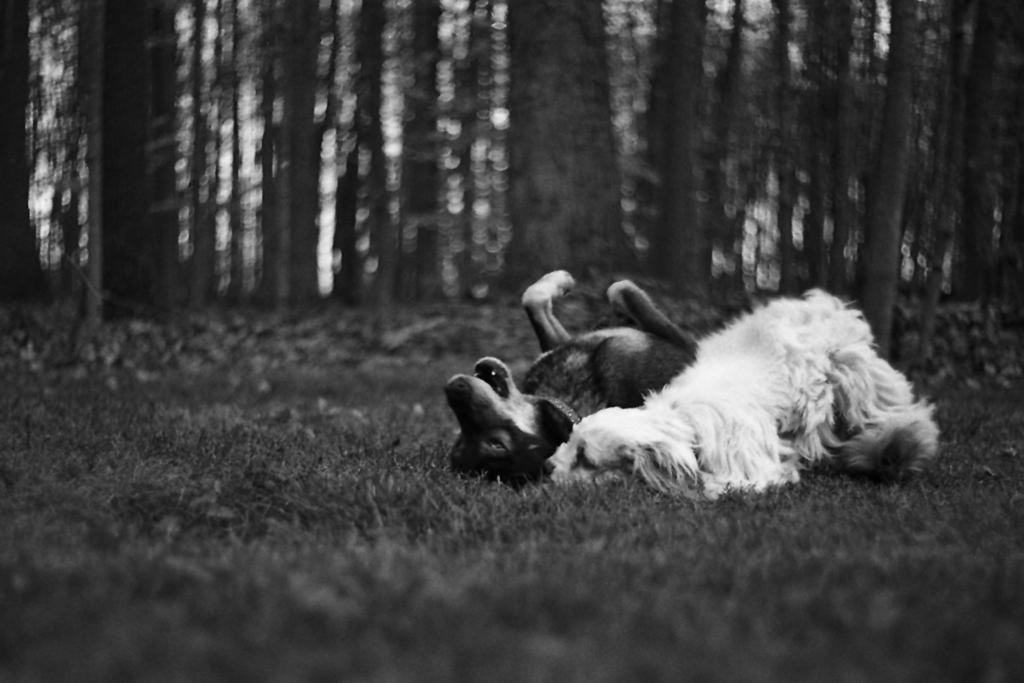What is the color scheme of the image? The image is black and white. How many dogs are present in the image? There are two dogs in the image. What are the dogs doing in the image? The dogs are lying on the grass. Can you describe the background of the image? The background of the image is blurred, and trees are visible. Where are the dolls placed in the image? There are no dolls present in the image. What type of clover can be seen growing in the image? There is no clover visible in the image; it features two dogs lying on the grass with a blurred background and trees. 